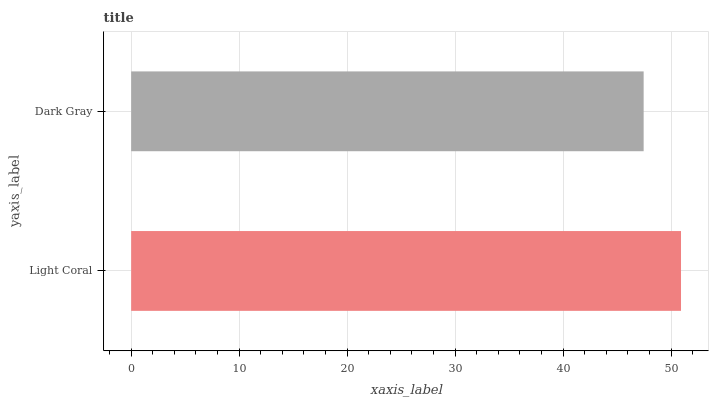Is Dark Gray the minimum?
Answer yes or no. Yes. Is Light Coral the maximum?
Answer yes or no. Yes. Is Dark Gray the maximum?
Answer yes or no. No. Is Light Coral greater than Dark Gray?
Answer yes or no. Yes. Is Dark Gray less than Light Coral?
Answer yes or no. Yes. Is Dark Gray greater than Light Coral?
Answer yes or no. No. Is Light Coral less than Dark Gray?
Answer yes or no. No. Is Light Coral the high median?
Answer yes or no. Yes. Is Dark Gray the low median?
Answer yes or no. Yes. Is Dark Gray the high median?
Answer yes or no. No. Is Light Coral the low median?
Answer yes or no. No. 